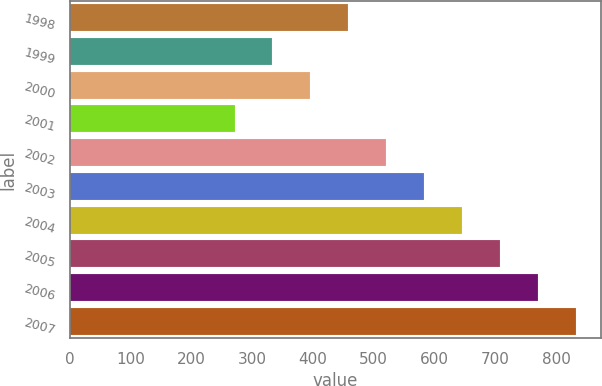Convert chart. <chart><loc_0><loc_0><loc_500><loc_500><bar_chart><fcel>1998<fcel>1999<fcel>2000<fcel>2001<fcel>2002<fcel>2003<fcel>2004<fcel>2005<fcel>2006<fcel>2007<nl><fcel>458.2<fcel>333.4<fcel>395.8<fcel>271<fcel>520.6<fcel>583<fcel>645.4<fcel>707.8<fcel>770.2<fcel>832.6<nl></chart> 